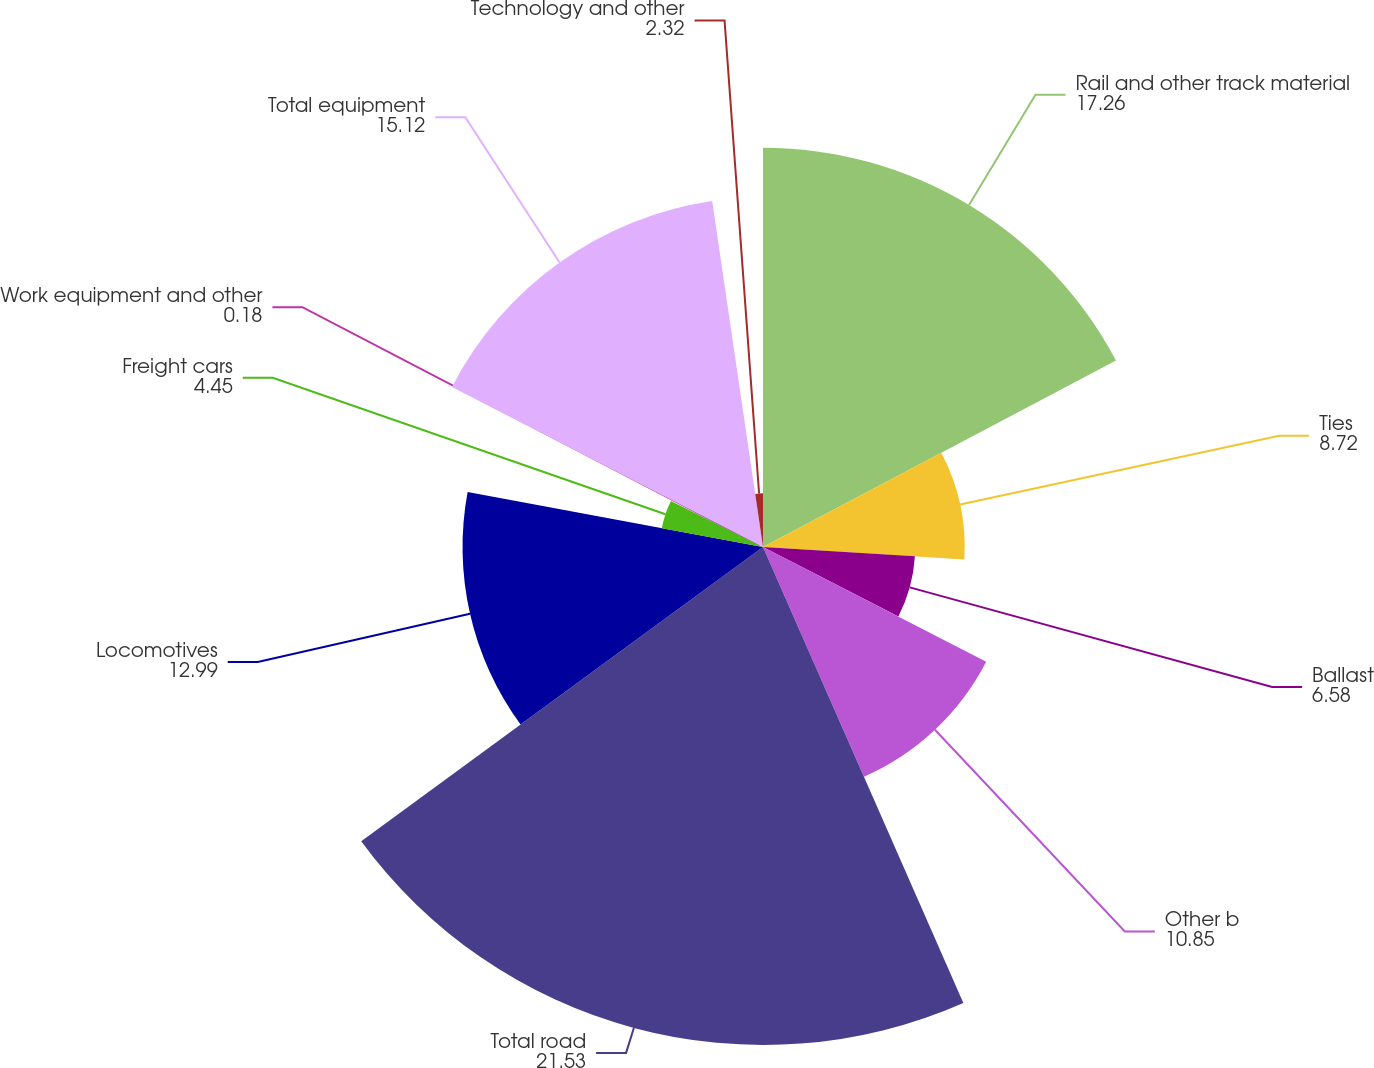Convert chart to OTSL. <chart><loc_0><loc_0><loc_500><loc_500><pie_chart><fcel>Rail and other track material<fcel>Ties<fcel>Ballast<fcel>Other b<fcel>Total road<fcel>Locomotives<fcel>Freight cars<fcel>Work equipment and other<fcel>Total equipment<fcel>Technology and other<nl><fcel>17.26%<fcel>8.72%<fcel>6.58%<fcel>10.85%<fcel>21.53%<fcel>12.99%<fcel>4.45%<fcel>0.18%<fcel>15.12%<fcel>2.32%<nl></chart> 